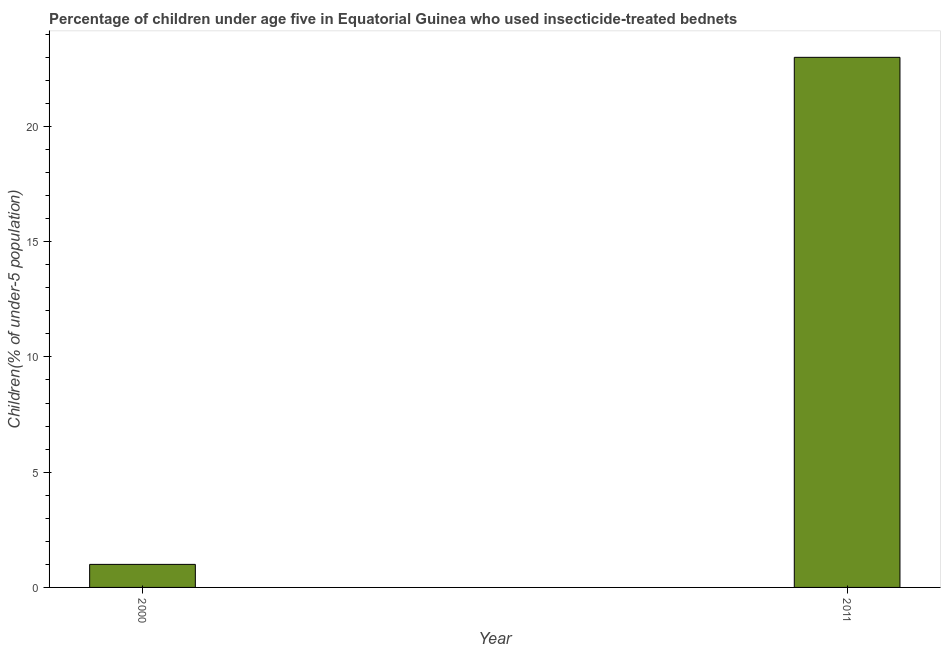Does the graph contain any zero values?
Give a very brief answer. No. Does the graph contain grids?
Keep it short and to the point. No. What is the title of the graph?
Your answer should be compact. Percentage of children under age five in Equatorial Guinea who used insecticide-treated bednets. What is the label or title of the X-axis?
Your answer should be very brief. Year. What is the label or title of the Y-axis?
Offer a terse response. Children(% of under-5 population). What is the percentage of children who use of insecticide-treated bed nets in 2011?
Keep it short and to the point. 23. Across all years, what is the maximum percentage of children who use of insecticide-treated bed nets?
Offer a very short reply. 23. What is the difference between the percentage of children who use of insecticide-treated bed nets in 2000 and 2011?
Provide a succinct answer. -22. What is the average percentage of children who use of insecticide-treated bed nets per year?
Provide a short and direct response. 12. What is the median percentage of children who use of insecticide-treated bed nets?
Provide a succinct answer. 12. In how many years, is the percentage of children who use of insecticide-treated bed nets greater than 12 %?
Offer a terse response. 1. Do a majority of the years between 2000 and 2011 (inclusive) have percentage of children who use of insecticide-treated bed nets greater than 10 %?
Your answer should be very brief. No. What is the ratio of the percentage of children who use of insecticide-treated bed nets in 2000 to that in 2011?
Keep it short and to the point. 0.04. Is the percentage of children who use of insecticide-treated bed nets in 2000 less than that in 2011?
Offer a very short reply. Yes. In how many years, is the percentage of children who use of insecticide-treated bed nets greater than the average percentage of children who use of insecticide-treated bed nets taken over all years?
Your answer should be compact. 1. Are all the bars in the graph horizontal?
Your response must be concise. No. How many years are there in the graph?
Make the answer very short. 2. What is the difference between two consecutive major ticks on the Y-axis?
Provide a succinct answer. 5. Are the values on the major ticks of Y-axis written in scientific E-notation?
Your answer should be compact. No. What is the Children(% of under-5 population) in 2000?
Ensure brevity in your answer.  1. What is the ratio of the Children(% of under-5 population) in 2000 to that in 2011?
Keep it short and to the point. 0.04. 